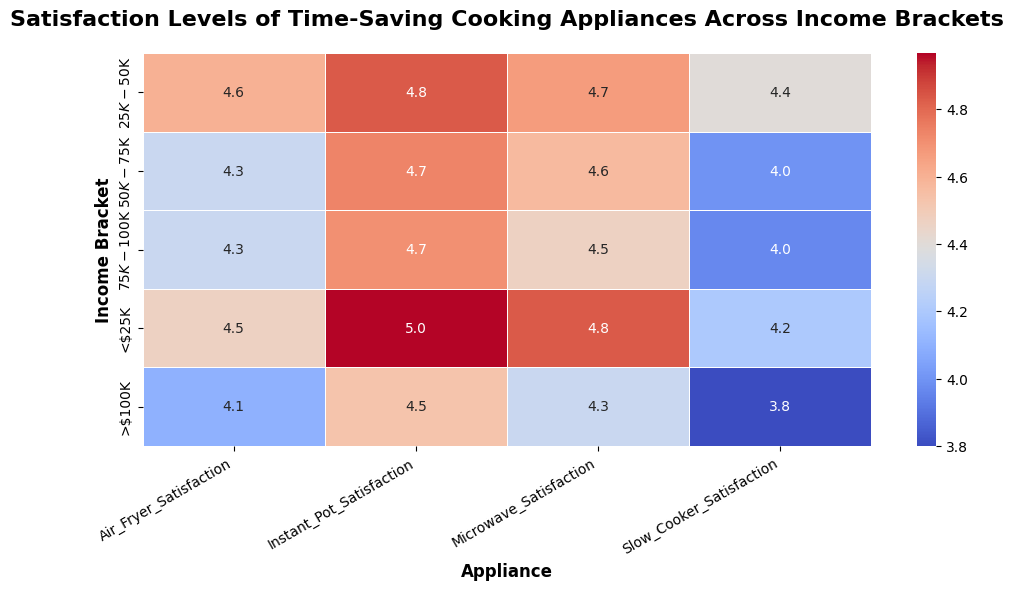Which income bracket has the highest satisfaction level with the Instant Pot? To find the highest satisfaction level with the Instant Pot, look at the column for Instant Pot Satisfaction and scan for the maximum value.
Answer: <$25K Which income bracket has the lowest satisfaction for slow cookers? Examine the Slow Cooker Satisfaction column and identify the income bracket with the minimum satisfaction level.
Answer: >$100K Which appliance has the most consistent satisfaction across all income brackets? Consistency can be measured by looking at the difference between the highest and lowest satisfaction scores for each appliance. The microwave has the least variation in scores across all income brackets.
Answer: Microwave What is the average satisfaction level for air fryers across all income brackets? Sum the air fryer satisfaction levels and divide by the number of income brackets: (4.5 + 4.6 + 4.2 + 4.4 + 4.1 + 4.3 + 4.7 + 4.3 + 4.2 + 4.0 + 4.6 + 4.5 + 4.4 + 4.3 + 4.2)/15 = 4.36.
Answer: 4.36 Which income bracket shows the greatest difference in satisfaction levels between the highest-rated and lowest-rated appliance? Calculate the difference between the highest and lowest satisfaction levels within each income bracket. The bracket with the largest difference is <$25K (5.0 - 4.2 = 0.8).
Answer: <$25K Is the satisfaction level for instant pots generally higher or lower than that of slow cookers? Compare the Instant Pot Satisfaction and Slow Cooker Satisfaction across all income brackets. Instant Pot Satisfaction values are generally higher than those for slow cookers.
Answer: Higher What is the average satisfaction level for the <$25K income bracket across all appliances? Compute the average of all satisfaction levels within the <$25K income bracket: (4.5 + 5.0 + 4.8 + 4.2 + 4.3 + 5.0 + 4.9 + 4.1 + 4.6 + 4.9 + 4.8 + 4.3)/12 = 4.6.
Answer: 4.6 For which income bracket is microwave satisfaction above 4.7? Check the Microwave Satisfaction values and identify income brackets with scores above 4.7. The income brackets are <$25K.
Answer: <$25K Which income bracket has its highest satisfaction level for the air fryer? Locate the highest satisfaction value in the Air Fryer Satisfaction column and find its corresponding income bracket. The income bracket is $25K-$50K (4.7).
Answer: $25K-$50K 